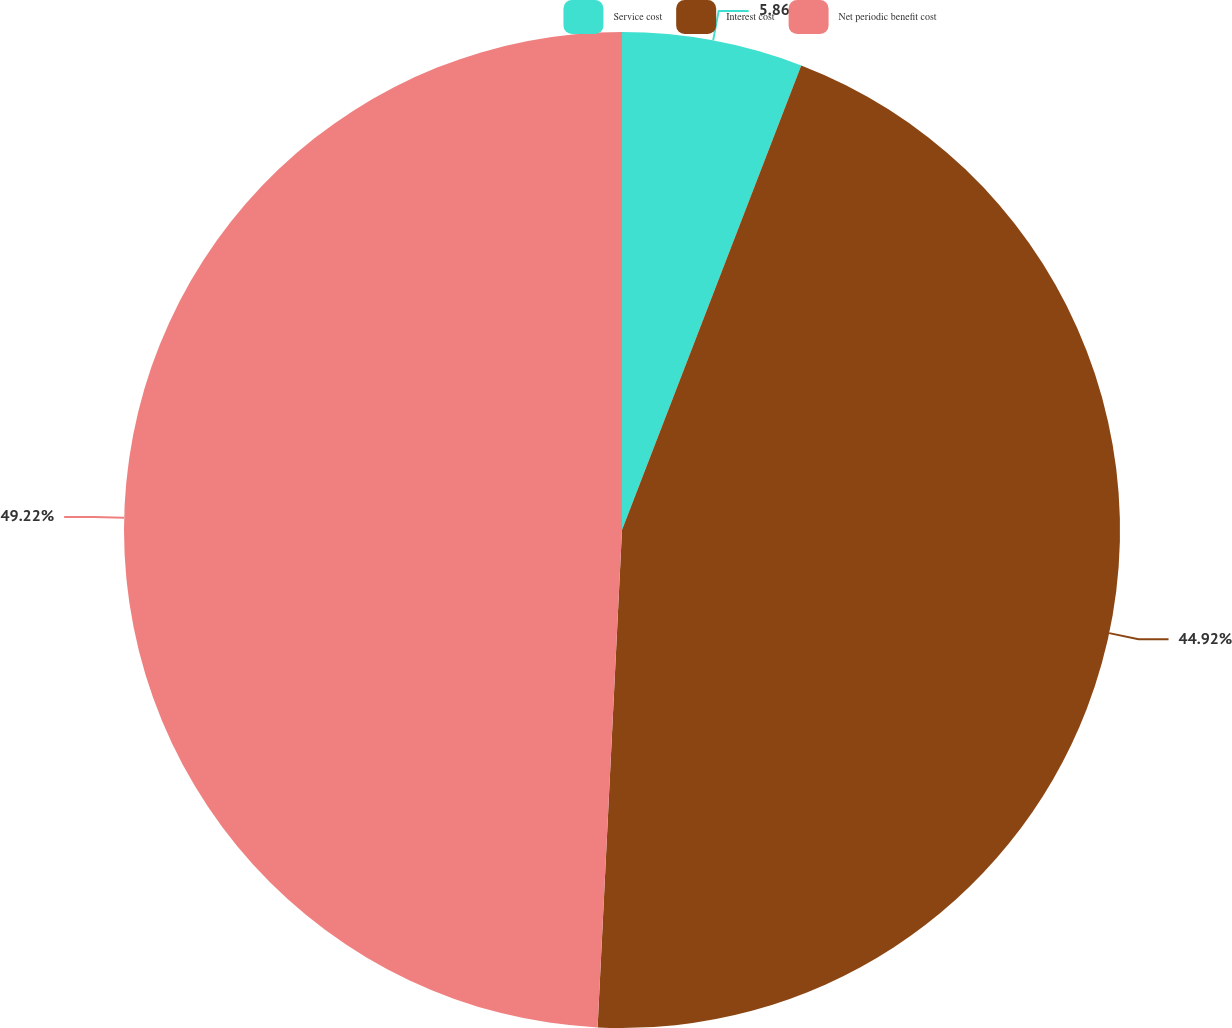Convert chart to OTSL. <chart><loc_0><loc_0><loc_500><loc_500><pie_chart><fcel>Service cost<fcel>Interest cost<fcel>Net periodic benefit cost<nl><fcel>5.86%<fcel>44.92%<fcel>49.22%<nl></chart> 